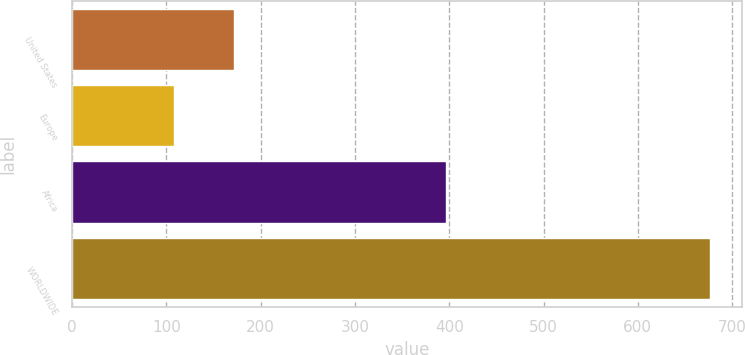<chart> <loc_0><loc_0><loc_500><loc_500><bar_chart><fcel>United States<fcel>Europe<fcel>Africa<fcel>WORLDWIDE<nl><fcel>172<fcel>108<fcel>397<fcel>677<nl></chart> 